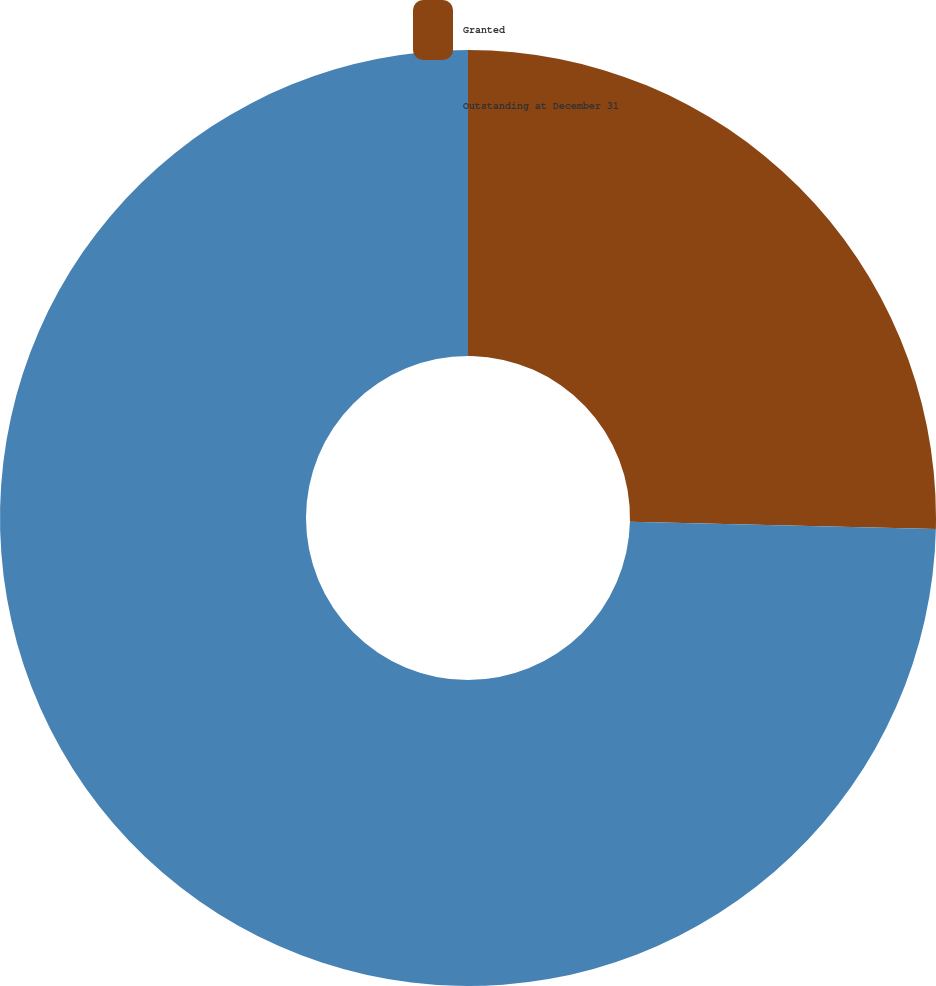Convert chart to OTSL. <chart><loc_0><loc_0><loc_500><loc_500><pie_chart><fcel>Granted<fcel>Outstanding at December 31<nl><fcel>25.37%<fcel>74.63%<nl></chart> 